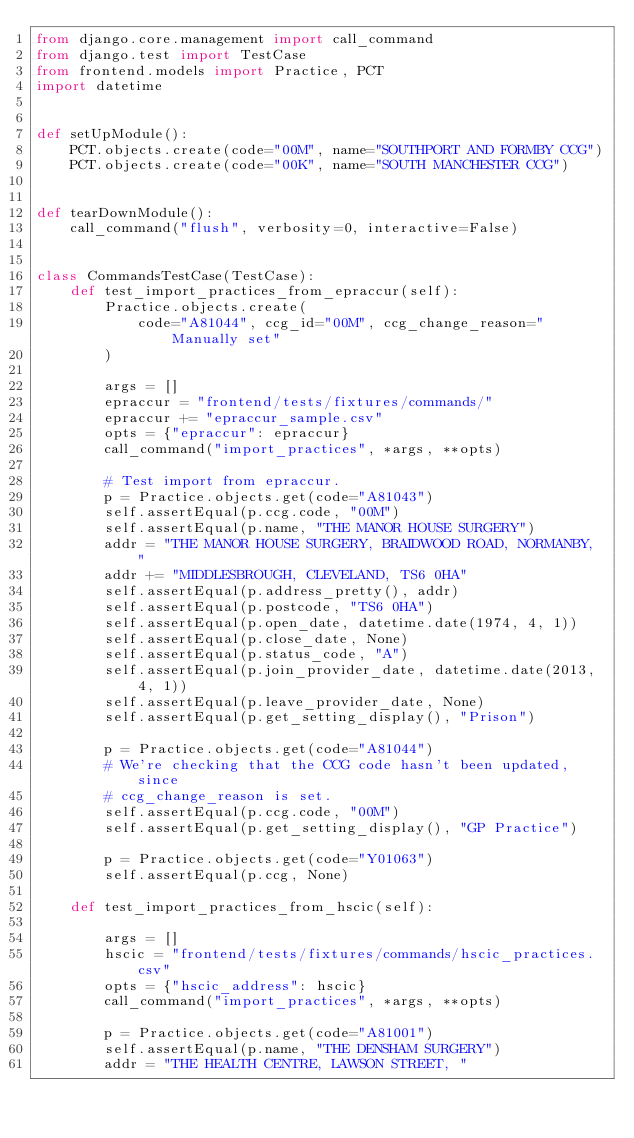Convert code to text. <code><loc_0><loc_0><loc_500><loc_500><_Python_>from django.core.management import call_command
from django.test import TestCase
from frontend.models import Practice, PCT
import datetime


def setUpModule():
    PCT.objects.create(code="00M", name="SOUTHPORT AND FORMBY CCG")
    PCT.objects.create(code="00K", name="SOUTH MANCHESTER CCG")


def tearDownModule():
    call_command("flush", verbosity=0, interactive=False)


class CommandsTestCase(TestCase):
    def test_import_practices_from_epraccur(self):
        Practice.objects.create(
            code="A81044", ccg_id="00M", ccg_change_reason="Manually set"
        )

        args = []
        epraccur = "frontend/tests/fixtures/commands/"
        epraccur += "epraccur_sample.csv"
        opts = {"epraccur": epraccur}
        call_command("import_practices", *args, **opts)

        # Test import from epraccur.
        p = Practice.objects.get(code="A81043")
        self.assertEqual(p.ccg.code, "00M")
        self.assertEqual(p.name, "THE MANOR HOUSE SURGERY")
        addr = "THE MANOR HOUSE SURGERY, BRAIDWOOD ROAD, NORMANBY, "
        addr += "MIDDLESBROUGH, CLEVELAND, TS6 0HA"
        self.assertEqual(p.address_pretty(), addr)
        self.assertEqual(p.postcode, "TS6 0HA")
        self.assertEqual(p.open_date, datetime.date(1974, 4, 1))
        self.assertEqual(p.close_date, None)
        self.assertEqual(p.status_code, "A")
        self.assertEqual(p.join_provider_date, datetime.date(2013, 4, 1))
        self.assertEqual(p.leave_provider_date, None)
        self.assertEqual(p.get_setting_display(), "Prison")

        p = Practice.objects.get(code="A81044")
        # We're checking that the CCG code hasn't been updated, since
        # ccg_change_reason is set.
        self.assertEqual(p.ccg.code, "00M")
        self.assertEqual(p.get_setting_display(), "GP Practice")

        p = Practice.objects.get(code="Y01063")
        self.assertEqual(p.ccg, None)

    def test_import_practices_from_hscic(self):

        args = []
        hscic = "frontend/tests/fixtures/commands/hscic_practices.csv"
        opts = {"hscic_address": hscic}
        call_command("import_practices", *args, **opts)

        p = Practice.objects.get(code="A81001")
        self.assertEqual(p.name, "THE DENSHAM SURGERY")
        addr = "THE HEALTH CENTRE, LAWSON STREET, "</code> 